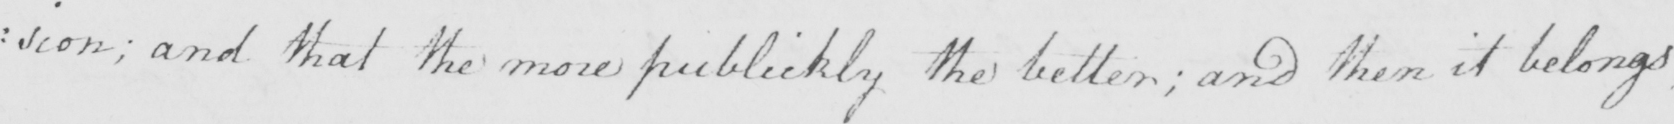What is written in this line of handwriting? : sion ; and that the more publickly the better ; and then it belongs 